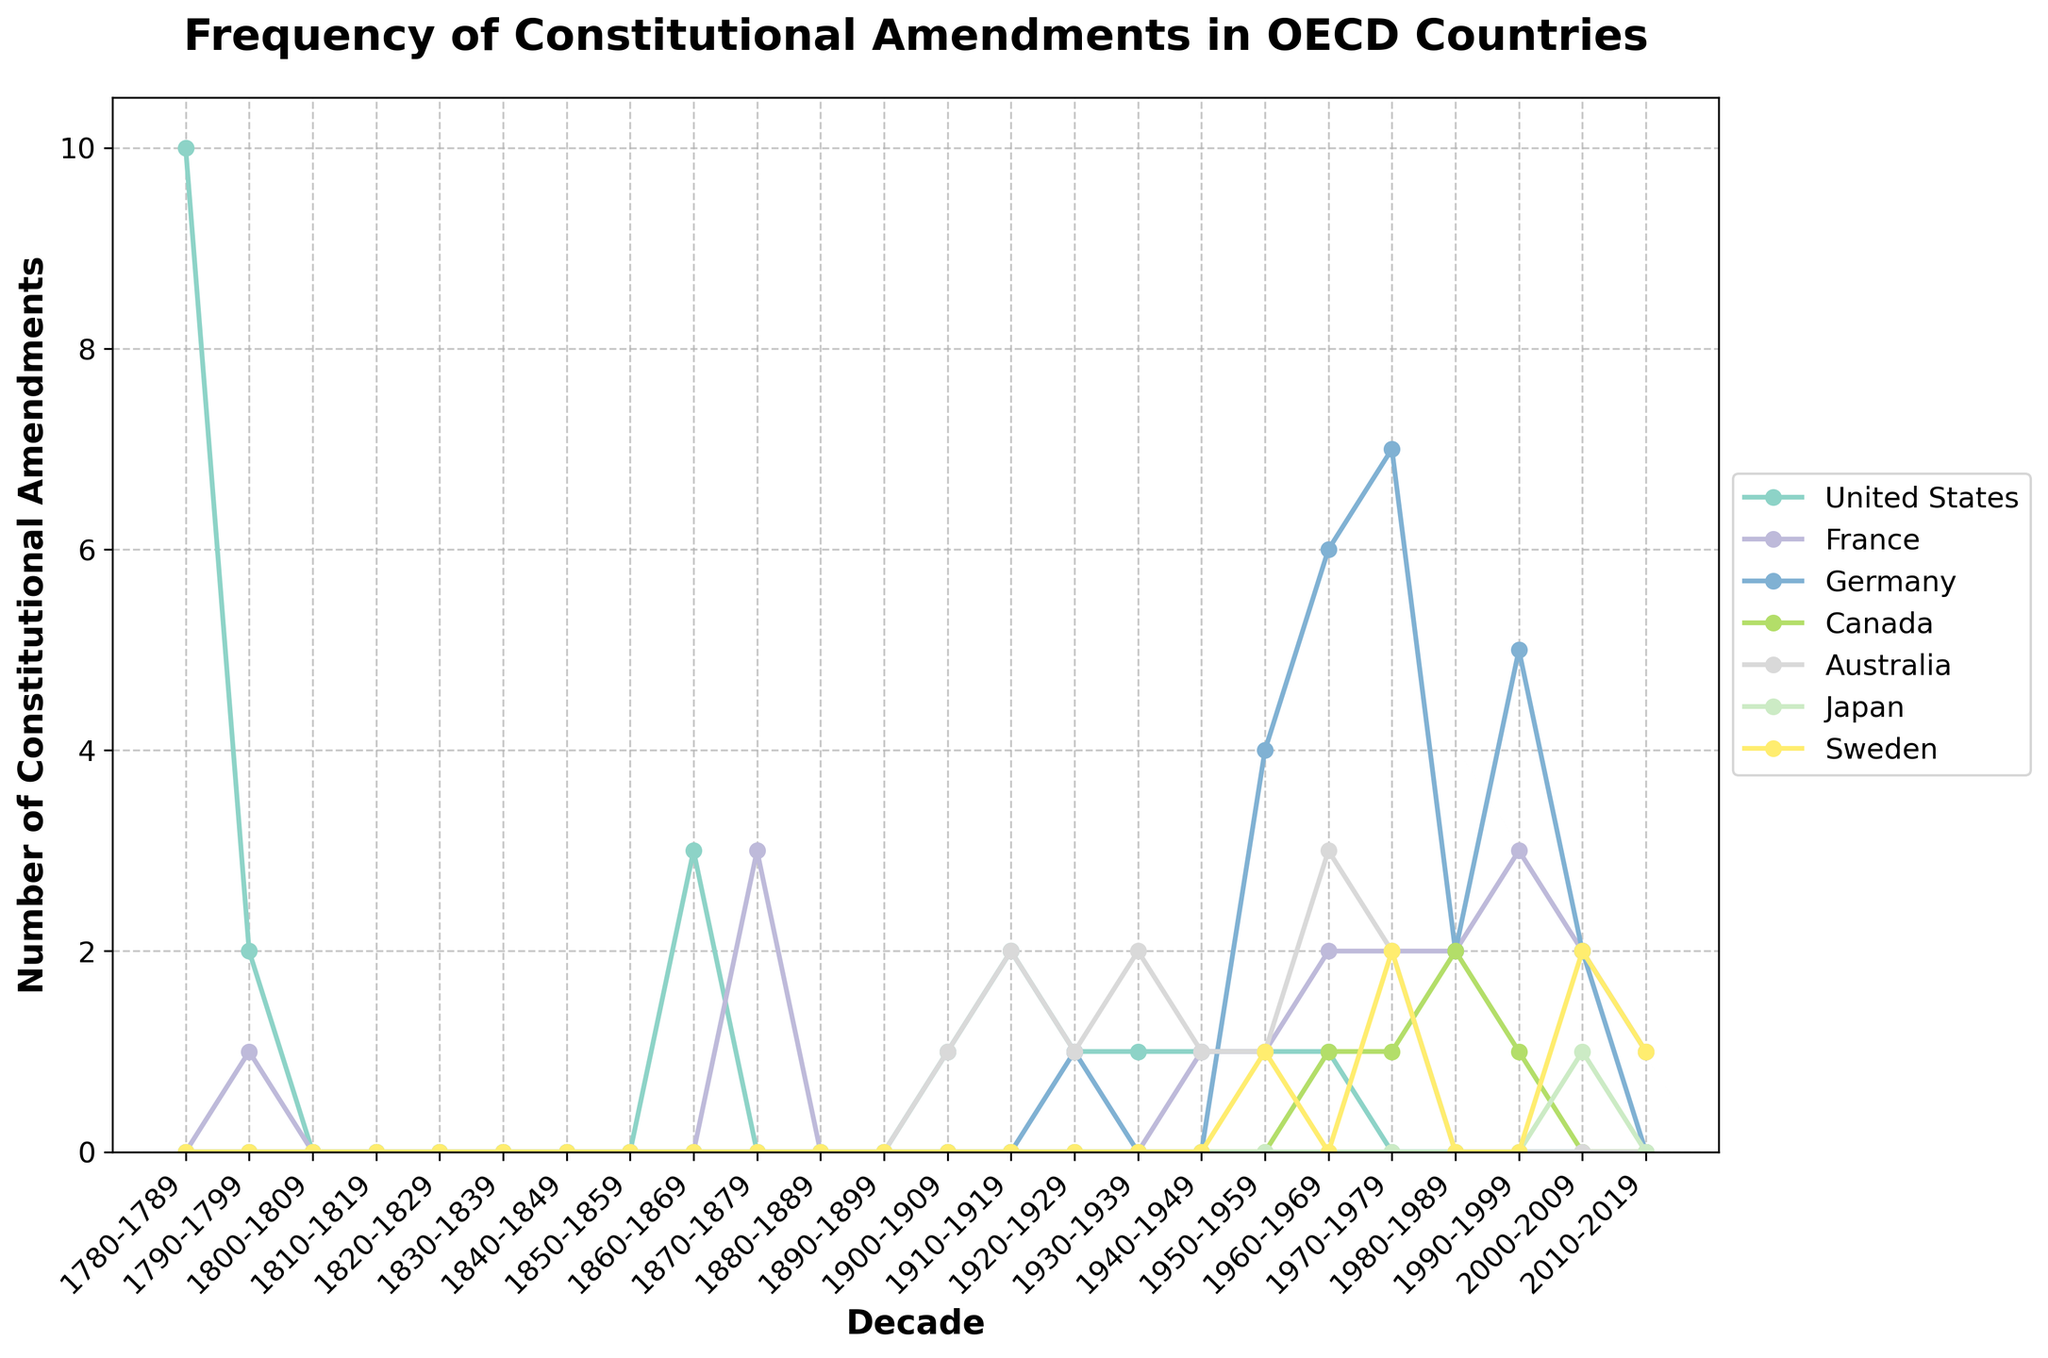what is the trend in constitutional amendments in Germany from 1940-2019? Observing Germany's line, it starts at 0 in the 1940s, rises to a peak of 7 in the 1970s, then drops and fluctuates between 2 and 5 amendments from the 1980s to 2000s, before hitting 0 again in the 2010s.
Answer: fluctuating with a peak around the 1970s Which country had the highest number of constitutional amendments in a single decade? By examining the peaks of each line, it's evident that Germany had the highest peak with 7 amendments in the 1970s.
Answer: Germany Between which decades did France see the most significant increase in constitutional amendments? Looking at France's line, the most noticeable increase happened between the 1950s and 1960s, where the count rose from 1 to 2 amendments.
Answer: 1950s to 1960s Compare the number of amendments in the United States and Japan during 2000-2009. Which country had more? Referring to both lines in the 2000-2009 period, the United States had 0 amendments while Japan had 1 amendment.
Answer: Japan In which decade did Australia see the highest number of amendments and what was the count? Observing Australia’s line, the highest number appears in the 1960s with a count of 3 amendments.
Answer: 1960s, 3 Was there a decade in which Canada had constitutional amendments but Australia did not? If so, which one? Reviewing both lines, the 1980s show Canada with 2 amendments and Australia with 0 amendments.
Answer: 1980s How many decades did Sweden have no constitutional amendments? Tracing Sweden’s line, they had no amendments in the periods 1780s-1950s, 1960s, 1980s, and early 2000s–2010s 
(7 decades).
Answer: 7 Which country had the more fluctuating pattern of constitutional amendments over the decades, France or Canada? France's line shows greater fluctuation, ranging between 0 and 3 over several decades, compared to Canada which generally remains around 0-2.
Answer: France What was the total number of amendments in Germany and France in the 1990s? In the 1990s, Germany had 5 amendments and France had 3 amendments, summing up to 8 amendments.
Answer: 8 Did any country maintain a consistent count of 1 amendment per decade for any continuous 40-year period? By reviewing each line, none of the countries maintained a count of 1 amendment per decade consistently for a continuous 40-year period.
Answer: No 